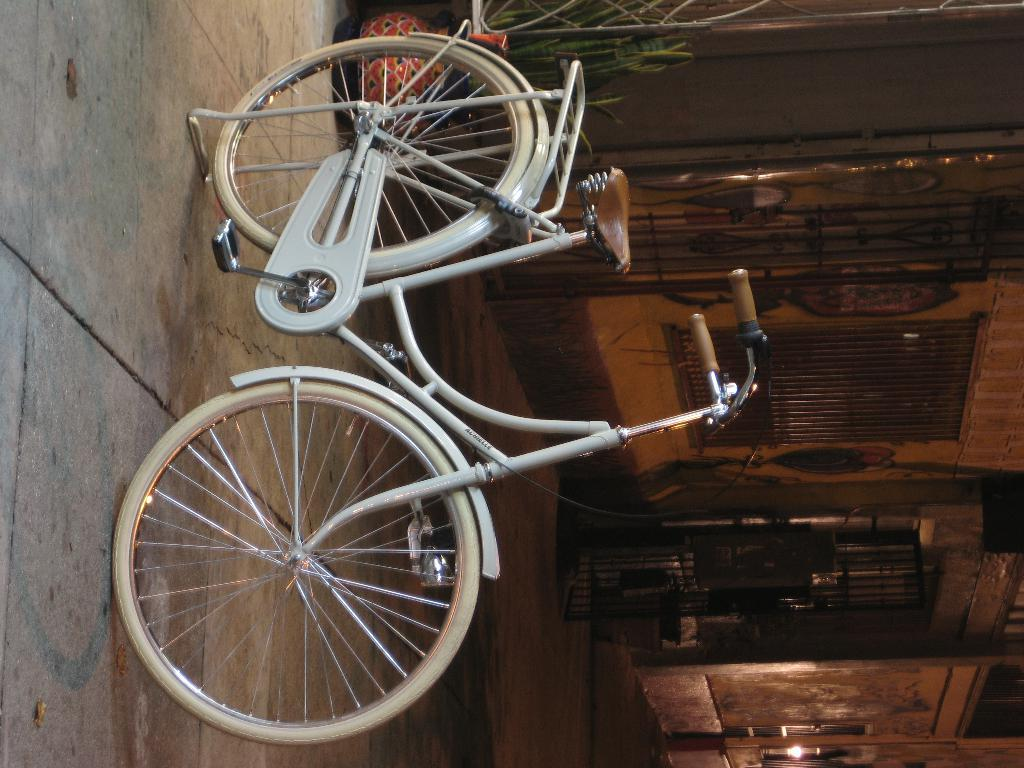What object is placed on the floor in the image? There is a cycle on the floor in the image. What can be seen in the background of the image? There are windows and a wall visible in the background of the image. What type of object is used for holding plants in the image? There is a plant pot in the image. What flavor of ice cream is being served at the dock in the image? There is no dock or ice cream present in the image. 